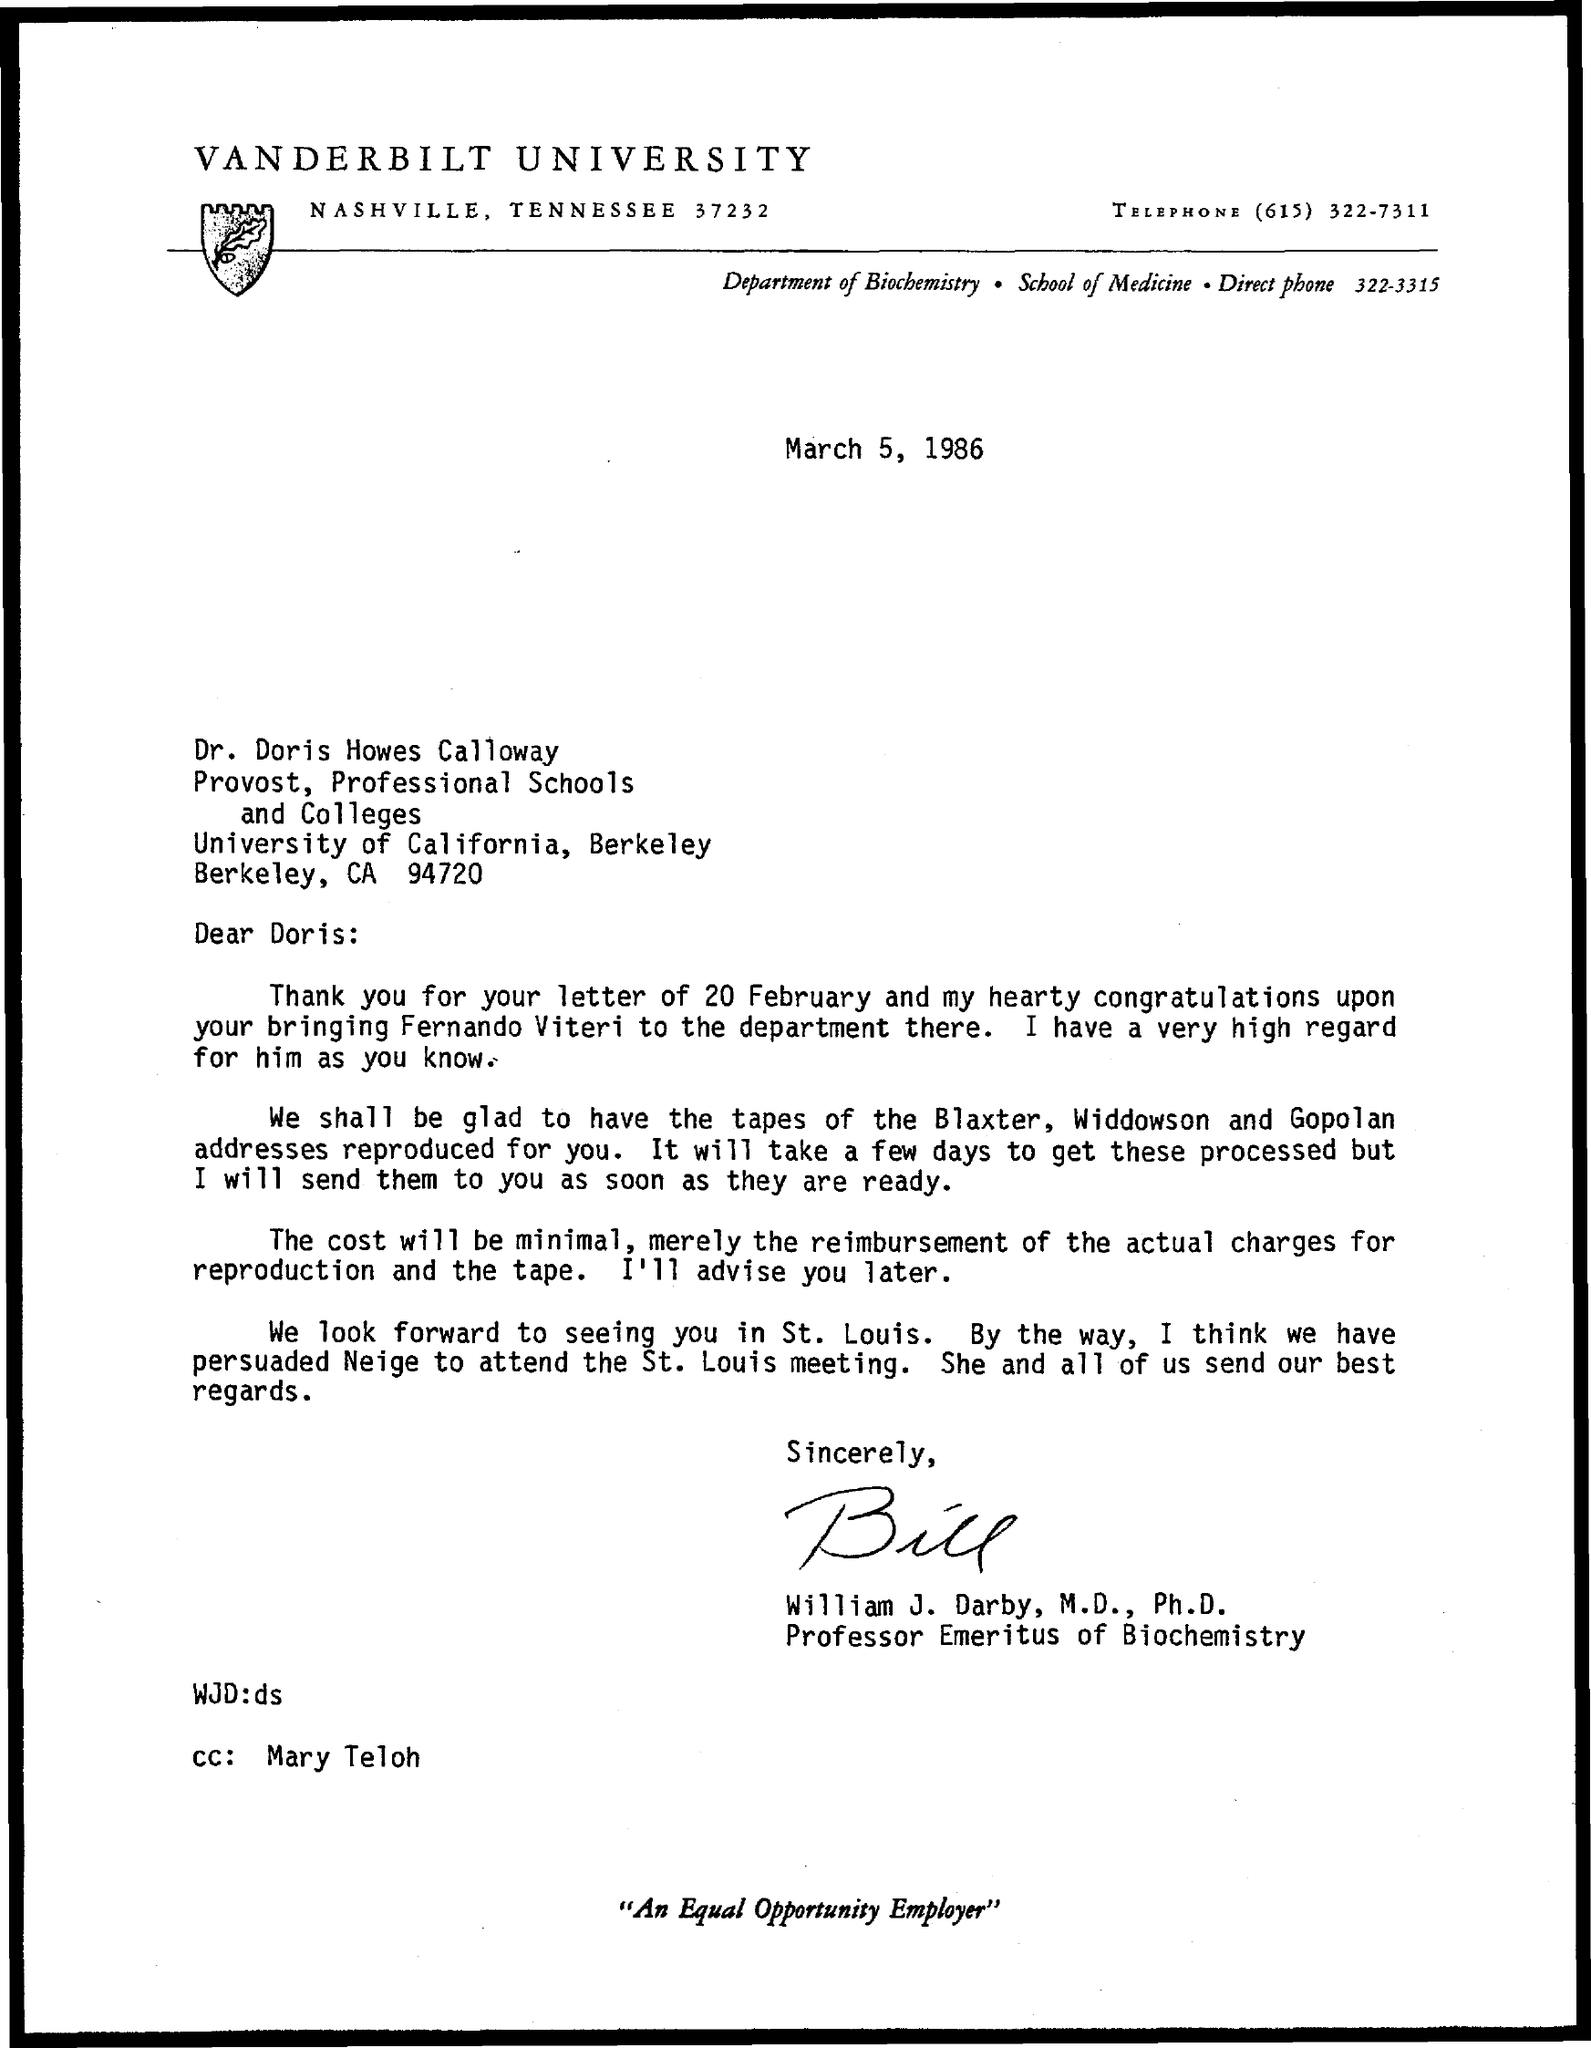Indicate a few pertinent items in this graphic. William J. Darby is Professor Emeritus of Biochemistry, with a designation of "Professor Emeritus of Biochemistry. According to the letter, the date mentioned is March 5, 1986. The telephone number mentioned in the given letter is (615) 322-7311. Vanderbilt University is named in the top of the letter. The Department of Biochemistry is the name of the department mentioned in the given letter. 